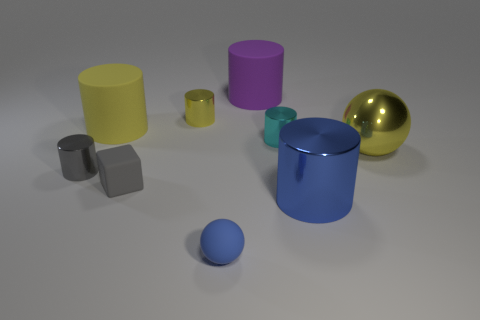How many small cylinders are made of the same material as the tiny gray block?
Offer a terse response. 0. How many big red rubber cylinders are there?
Your response must be concise. 0. There is a tiny rubber thing right of the small yellow cylinder; does it have the same color as the cylinder in front of the gray matte block?
Ensure brevity in your answer.  Yes. There is a purple rubber object; what number of things are to the right of it?
Provide a succinct answer. 3. What is the material of the large cylinder that is the same color as the big metal sphere?
Ensure brevity in your answer.  Rubber. Is there a small gray object that has the same shape as the small cyan metallic object?
Your answer should be compact. Yes. Are the large yellow thing that is left of the tiny yellow shiny object and the blue object that is to the right of the big purple matte cylinder made of the same material?
Your answer should be compact. No. How big is the yellow metal thing to the left of the yellow object that is on the right side of the metallic cylinder that is to the right of the cyan object?
Offer a very short reply. Small. There is a cube that is the same size as the gray shiny thing; what material is it?
Your answer should be very brief. Rubber. Is there another matte cylinder that has the same size as the purple rubber cylinder?
Keep it short and to the point. Yes. 